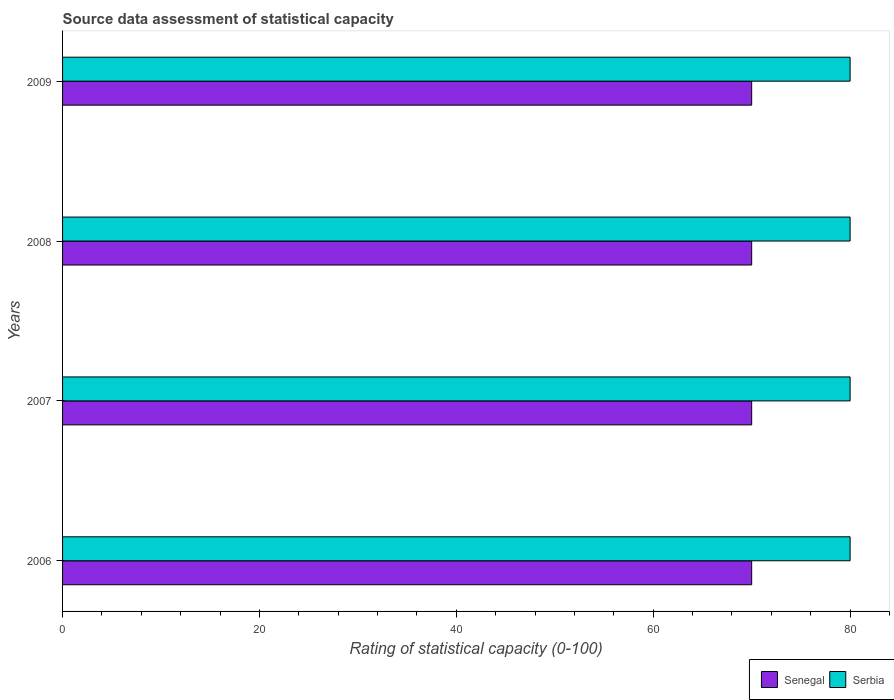How many different coloured bars are there?
Your answer should be very brief. 2. Are the number of bars on each tick of the Y-axis equal?
Offer a terse response. Yes. How many bars are there on the 1st tick from the bottom?
Your answer should be very brief. 2. What is the label of the 2nd group of bars from the top?
Your answer should be very brief. 2008. In how many cases, is the number of bars for a given year not equal to the number of legend labels?
Keep it short and to the point. 0. What is the rating of statistical capacity in Senegal in 2009?
Your answer should be compact. 70. Across all years, what is the maximum rating of statistical capacity in Serbia?
Offer a very short reply. 80. Across all years, what is the minimum rating of statistical capacity in Serbia?
Provide a short and direct response. 80. In which year was the rating of statistical capacity in Serbia maximum?
Your answer should be very brief. 2006. In which year was the rating of statistical capacity in Senegal minimum?
Make the answer very short. 2006. What is the total rating of statistical capacity in Serbia in the graph?
Keep it short and to the point. 320. What is the difference between the rating of statistical capacity in Senegal in 2008 and the rating of statistical capacity in Serbia in 2007?
Ensure brevity in your answer.  -10. What is the average rating of statistical capacity in Serbia per year?
Your response must be concise. 80. In the year 2007, what is the difference between the rating of statistical capacity in Senegal and rating of statistical capacity in Serbia?
Offer a very short reply. -10. In how many years, is the rating of statistical capacity in Serbia greater than 48 ?
Give a very brief answer. 4. What is the ratio of the rating of statistical capacity in Serbia in 2007 to that in 2008?
Make the answer very short. 1. Is the rating of statistical capacity in Serbia in 2007 less than that in 2009?
Your answer should be compact. No. What is the difference between the highest and the second highest rating of statistical capacity in Senegal?
Offer a very short reply. 0. What does the 2nd bar from the top in 2006 represents?
Provide a succinct answer. Senegal. What does the 2nd bar from the bottom in 2006 represents?
Offer a very short reply. Serbia. Are all the bars in the graph horizontal?
Keep it short and to the point. Yes. How many years are there in the graph?
Make the answer very short. 4. Are the values on the major ticks of X-axis written in scientific E-notation?
Your response must be concise. No. Does the graph contain any zero values?
Offer a terse response. No. Where does the legend appear in the graph?
Provide a succinct answer. Bottom right. How many legend labels are there?
Your answer should be very brief. 2. What is the title of the graph?
Your answer should be compact. Source data assessment of statistical capacity. What is the label or title of the X-axis?
Your response must be concise. Rating of statistical capacity (0-100). What is the label or title of the Y-axis?
Ensure brevity in your answer.  Years. What is the Rating of statistical capacity (0-100) of Senegal in 2006?
Give a very brief answer. 70. What is the Rating of statistical capacity (0-100) in Senegal in 2007?
Your response must be concise. 70. What is the Rating of statistical capacity (0-100) of Senegal in 2008?
Ensure brevity in your answer.  70. What is the Rating of statistical capacity (0-100) of Serbia in 2008?
Ensure brevity in your answer.  80. What is the Rating of statistical capacity (0-100) of Senegal in 2009?
Your answer should be very brief. 70. Across all years, what is the maximum Rating of statistical capacity (0-100) in Senegal?
Your response must be concise. 70. Across all years, what is the maximum Rating of statistical capacity (0-100) in Serbia?
Ensure brevity in your answer.  80. Across all years, what is the minimum Rating of statistical capacity (0-100) in Serbia?
Ensure brevity in your answer.  80. What is the total Rating of statistical capacity (0-100) in Senegal in the graph?
Offer a terse response. 280. What is the total Rating of statistical capacity (0-100) in Serbia in the graph?
Make the answer very short. 320. What is the difference between the Rating of statistical capacity (0-100) of Serbia in 2006 and that in 2007?
Provide a succinct answer. 0. What is the difference between the Rating of statistical capacity (0-100) of Senegal in 2006 and that in 2009?
Keep it short and to the point. 0. What is the difference between the Rating of statistical capacity (0-100) of Serbia in 2006 and that in 2009?
Give a very brief answer. 0. What is the difference between the Rating of statistical capacity (0-100) of Serbia in 2007 and that in 2009?
Provide a short and direct response. 0. What is the difference between the Rating of statistical capacity (0-100) of Senegal in 2008 and that in 2009?
Offer a terse response. 0. What is the difference between the Rating of statistical capacity (0-100) in Senegal in 2006 and the Rating of statistical capacity (0-100) in Serbia in 2009?
Keep it short and to the point. -10. What is the average Rating of statistical capacity (0-100) of Senegal per year?
Ensure brevity in your answer.  70. In the year 2008, what is the difference between the Rating of statistical capacity (0-100) in Senegal and Rating of statistical capacity (0-100) in Serbia?
Keep it short and to the point. -10. In the year 2009, what is the difference between the Rating of statistical capacity (0-100) in Senegal and Rating of statistical capacity (0-100) in Serbia?
Keep it short and to the point. -10. What is the ratio of the Rating of statistical capacity (0-100) of Senegal in 2006 to that in 2007?
Offer a very short reply. 1. What is the ratio of the Rating of statistical capacity (0-100) in Serbia in 2006 to that in 2007?
Offer a terse response. 1. What is the ratio of the Rating of statistical capacity (0-100) of Senegal in 2006 to that in 2008?
Your response must be concise. 1. What is the ratio of the Rating of statistical capacity (0-100) of Senegal in 2006 to that in 2009?
Your answer should be very brief. 1. What is the ratio of the Rating of statistical capacity (0-100) of Serbia in 2007 to that in 2009?
Keep it short and to the point. 1. What is the difference between the highest and the lowest Rating of statistical capacity (0-100) in Serbia?
Make the answer very short. 0. 